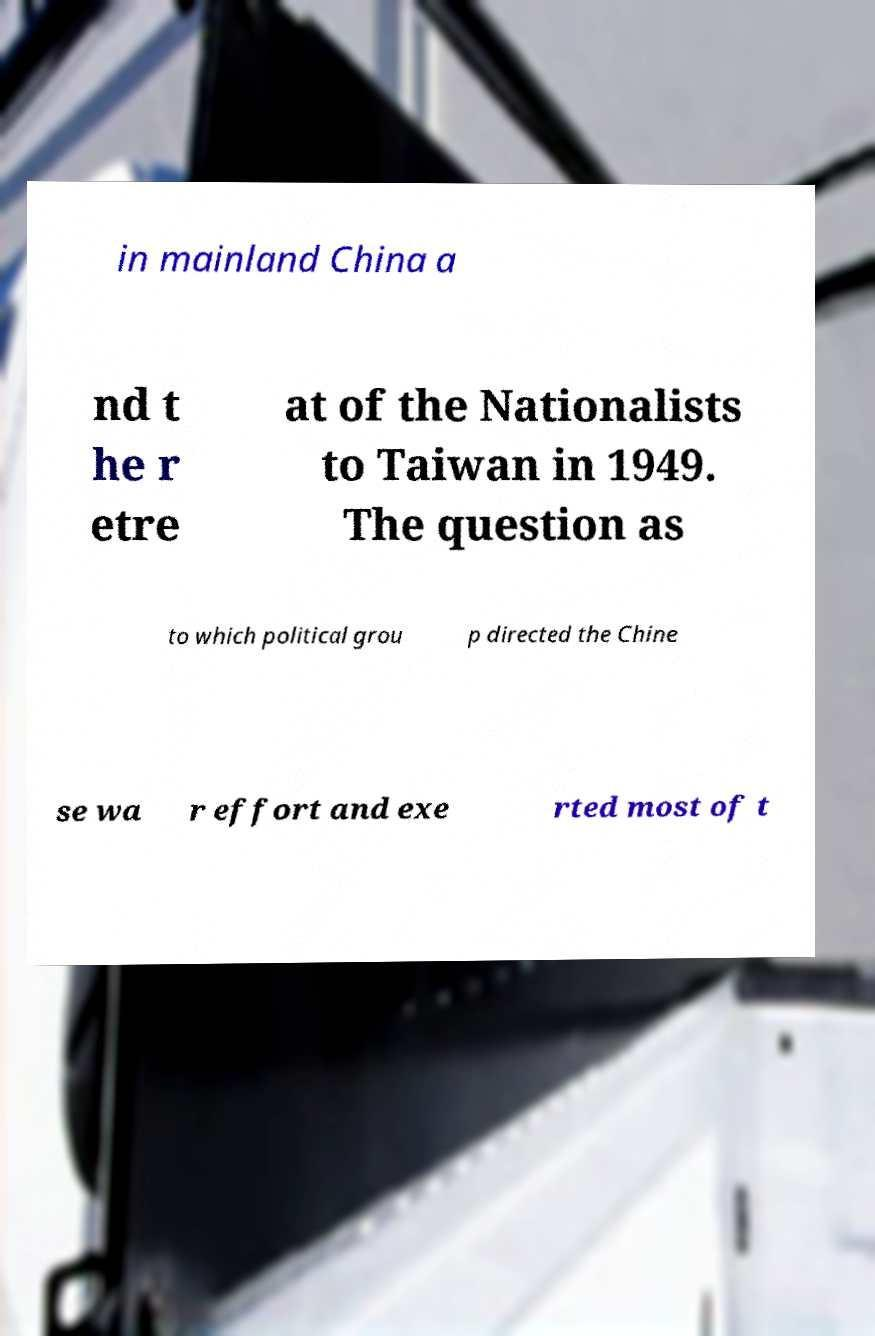Please identify and transcribe the text found in this image. in mainland China a nd t he r etre at of the Nationalists to Taiwan in 1949. The question as to which political grou p directed the Chine se wa r effort and exe rted most of t 